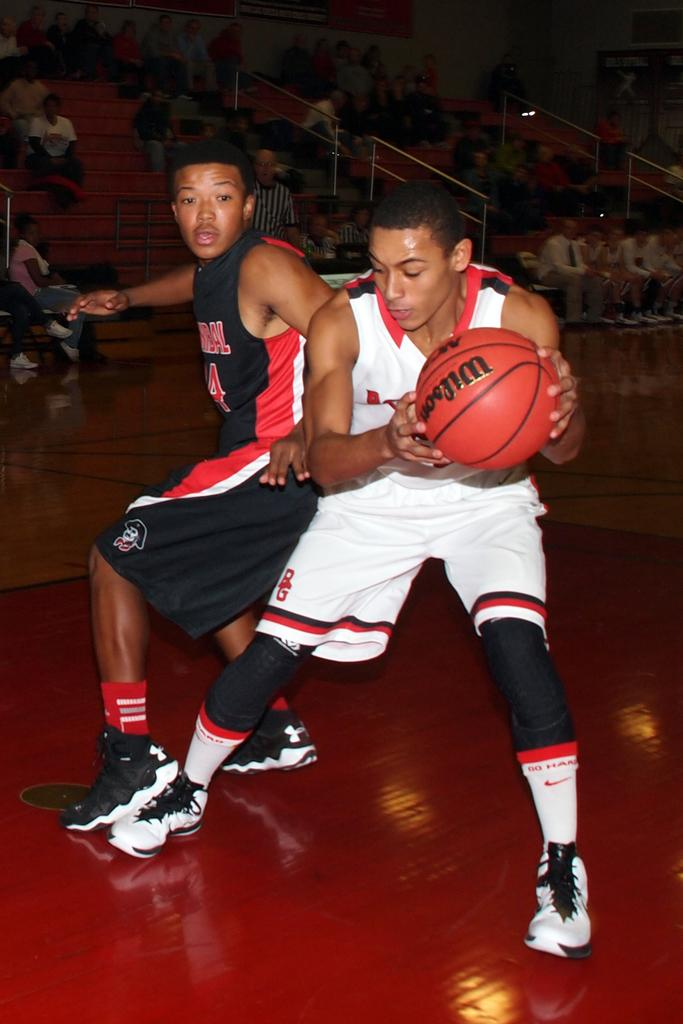<image>
Relay a brief, clear account of the picture shown. The basketball player held the basketball with the words "Wilson" written on it. 